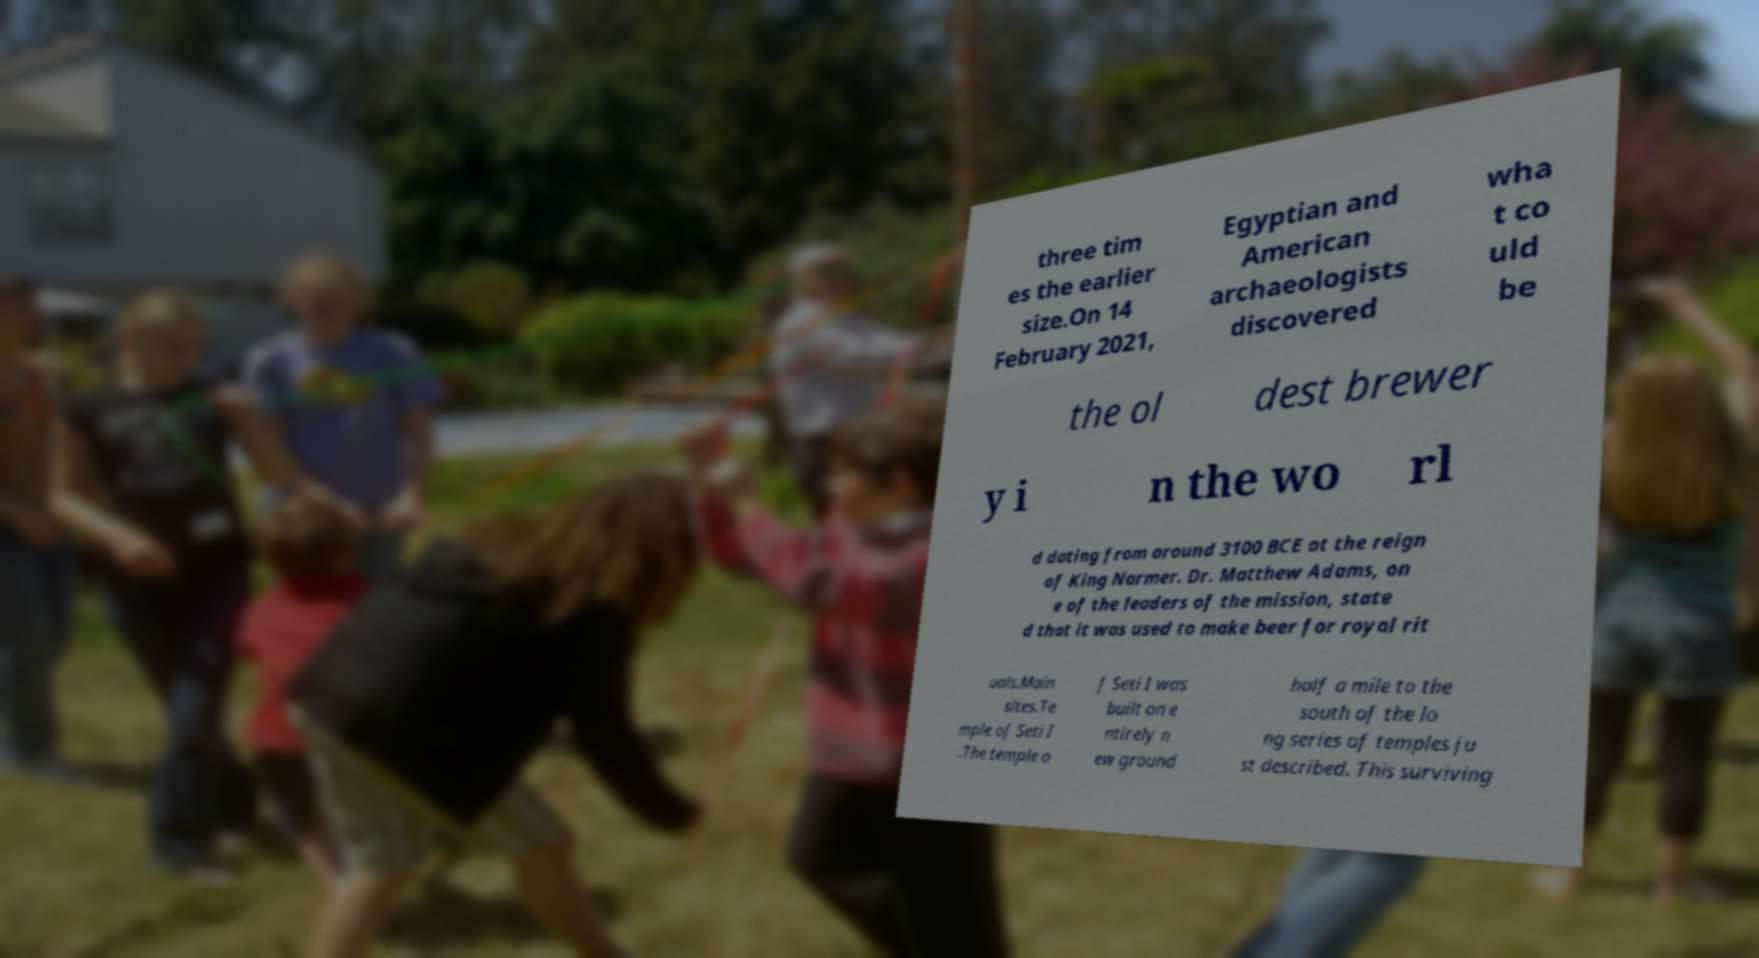There's text embedded in this image that I need extracted. Can you transcribe it verbatim? three tim es the earlier size.On 14 February 2021, Egyptian and American archaeologists discovered wha t co uld be the ol dest brewer y i n the wo rl d dating from around 3100 BCE at the reign of King Narmer. Dr. Matthew Adams, on e of the leaders of the mission, state d that it was used to make beer for royal rit uals.Main sites.Te mple of Seti I .The temple o f Seti I was built on e ntirely n ew ground half a mile to the south of the lo ng series of temples ju st described. This surviving 